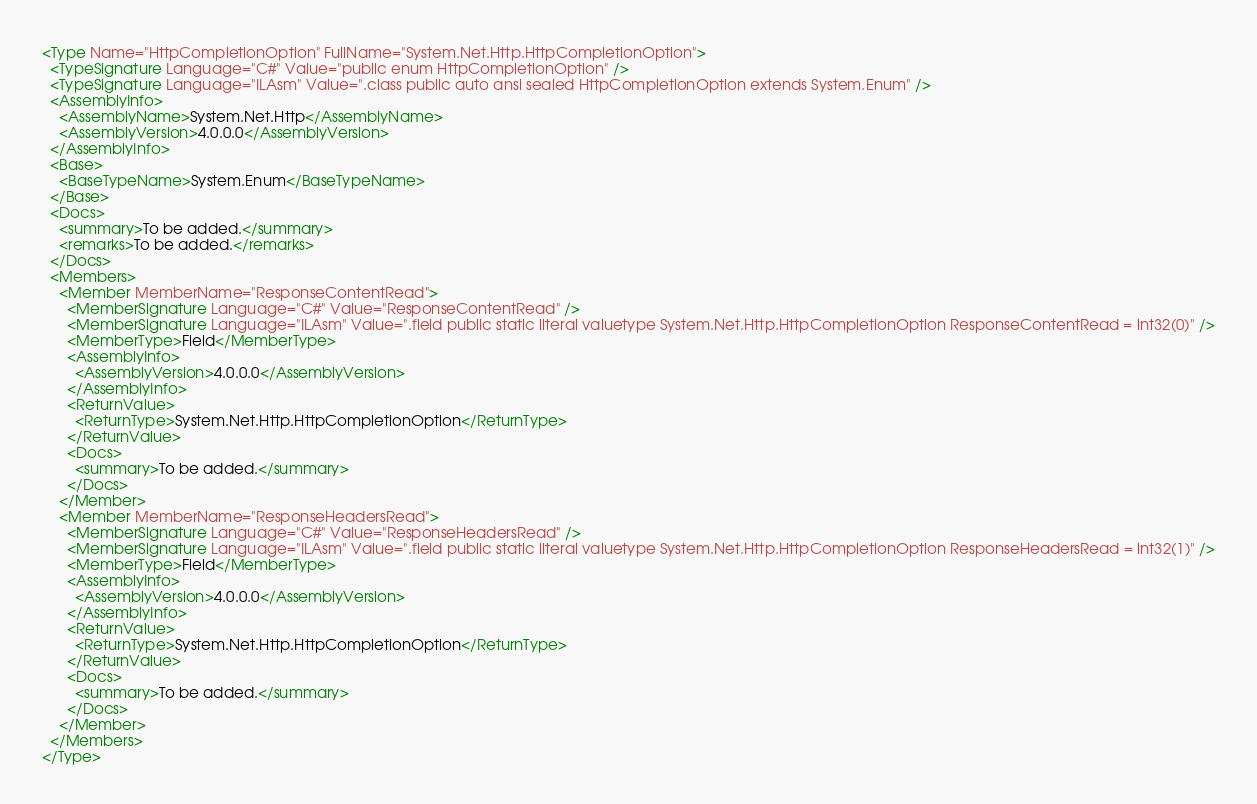<code> <loc_0><loc_0><loc_500><loc_500><_XML_><Type Name="HttpCompletionOption" FullName="System.Net.Http.HttpCompletionOption">
  <TypeSignature Language="C#" Value="public enum HttpCompletionOption" />
  <TypeSignature Language="ILAsm" Value=".class public auto ansi sealed HttpCompletionOption extends System.Enum" />
  <AssemblyInfo>
    <AssemblyName>System.Net.Http</AssemblyName>
    <AssemblyVersion>4.0.0.0</AssemblyVersion>
  </AssemblyInfo>
  <Base>
    <BaseTypeName>System.Enum</BaseTypeName>
  </Base>
  <Docs>
    <summary>To be added.</summary>
    <remarks>To be added.</remarks>
  </Docs>
  <Members>
    <Member MemberName="ResponseContentRead">
      <MemberSignature Language="C#" Value="ResponseContentRead" />
      <MemberSignature Language="ILAsm" Value=".field public static literal valuetype System.Net.Http.HttpCompletionOption ResponseContentRead = int32(0)" />
      <MemberType>Field</MemberType>
      <AssemblyInfo>
        <AssemblyVersion>4.0.0.0</AssemblyVersion>
      </AssemblyInfo>
      <ReturnValue>
        <ReturnType>System.Net.Http.HttpCompletionOption</ReturnType>
      </ReturnValue>
      <Docs>
        <summary>To be added.</summary>
      </Docs>
    </Member>
    <Member MemberName="ResponseHeadersRead">
      <MemberSignature Language="C#" Value="ResponseHeadersRead" />
      <MemberSignature Language="ILAsm" Value=".field public static literal valuetype System.Net.Http.HttpCompletionOption ResponseHeadersRead = int32(1)" />
      <MemberType>Field</MemberType>
      <AssemblyInfo>
        <AssemblyVersion>4.0.0.0</AssemblyVersion>
      </AssemblyInfo>
      <ReturnValue>
        <ReturnType>System.Net.Http.HttpCompletionOption</ReturnType>
      </ReturnValue>
      <Docs>
        <summary>To be added.</summary>
      </Docs>
    </Member>
  </Members>
</Type>
</code> 